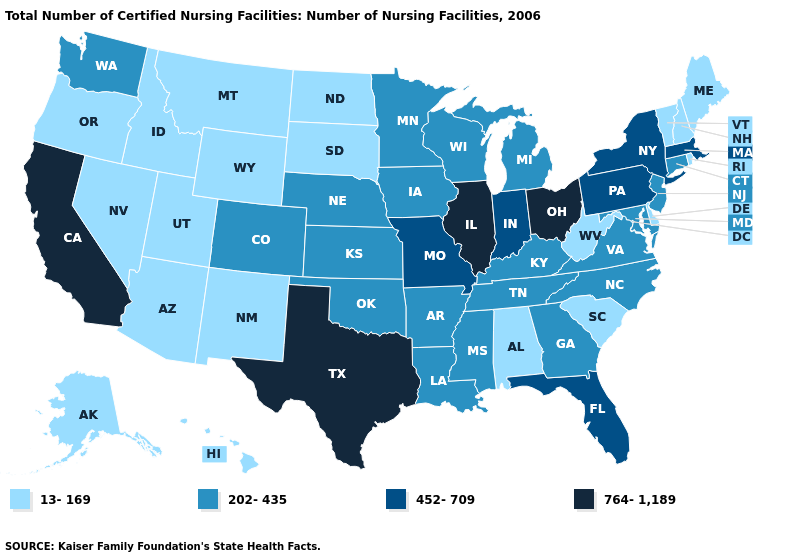Does Mississippi have a higher value than Idaho?
Write a very short answer. Yes. Among the states that border Wyoming , does Utah have the highest value?
Answer briefly. No. What is the value of Kentucky?
Concise answer only. 202-435. Among the states that border Wisconsin , does Minnesota have the highest value?
Quick response, please. No. Among the states that border Arizona , does Colorado have the lowest value?
Write a very short answer. No. Which states have the lowest value in the Northeast?
Give a very brief answer. Maine, New Hampshire, Rhode Island, Vermont. Name the states that have a value in the range 764-1,189?
Give a very brief answer. California, Illinois, Ohio, Texas. What is the highest value in the USA?
Quick response, please. 764-1,189. What is the highest value in the MidWest ?
Keep it brief. 764-1,189. Name the states that have a value in the range 202-435?
Short answer required. Arkansas, Colorado, Connecticut, Georgia, Iowa, Kansas, Kentucky, Louisiana, Maryland, Michigan, Minnesota, Mississippi, Nebraska, New Jersey, North Carolina, Oklahoma, Tennessee, Virginia, Washington, Wisconsin. Name the states that have a value in the range 764-1,189?
Answer briefly. California, Illinois, Ohio, Texas. Does Kentucky have a higher value than Indiana?
Answer briefly. No. Does Washington have the lowest value in the USA?
Quick response, please. No. Name the states that have a value in the range 13-169?
Quick response, please. Alabama, Alaska, Arizona, Delaware, Hawaii, Idaho, Maine, Montana, Nevada, New Hampshire, New Mexico, North Dakota, Oregon, Rhode Island, South Carolina, South Dakota, Utah, Vermont, West Virginia, Wyoming. Name the states that have a value in the range 764-1,189?
Write a very short answer. California, Illinois, Ohio, Texas. 